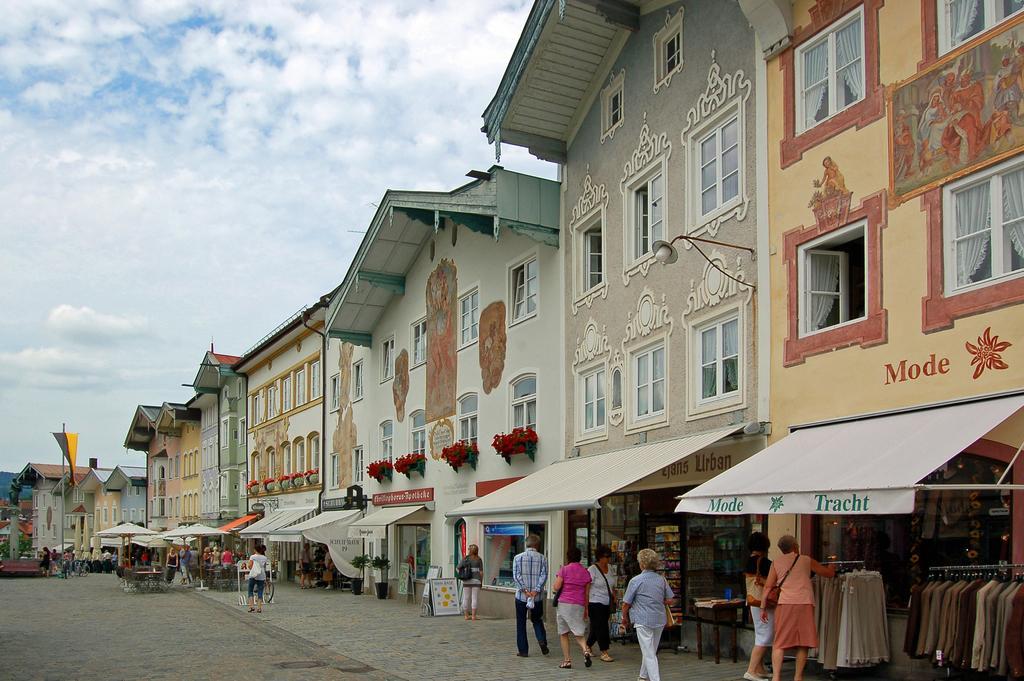Please provide a concise description of this image. In this image I can see group of people walking and I can also see few stalls, buildings, windows and the sky is in blue and white color. 